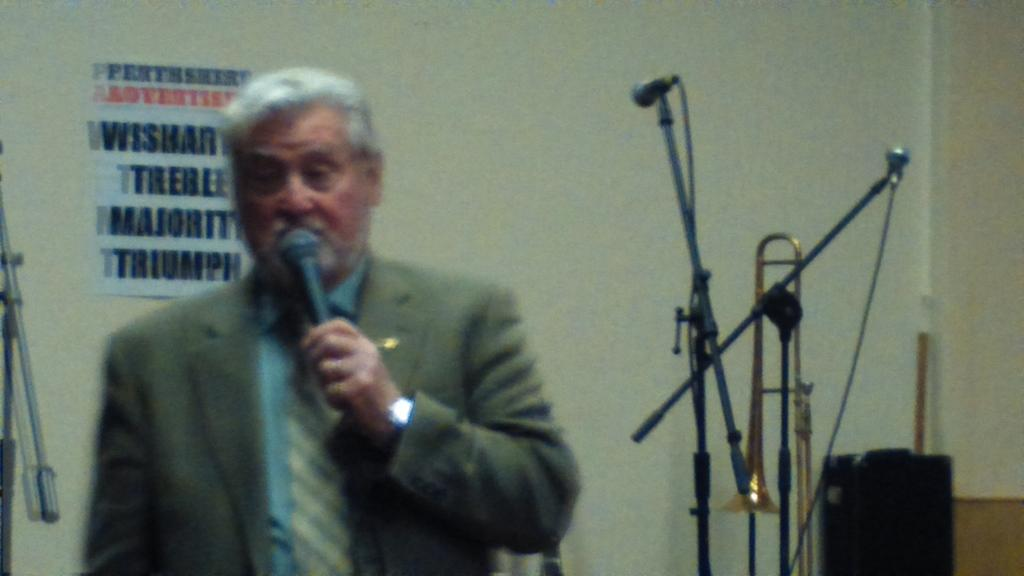What is the man in the image doing? The man is standing and talking into a microphone. What can be seen in the background of the image? There are microphones, trombones, a wall, a wall poster, and a speaker in the background of the image. How many microphones are visible in the image? There is one microphone being used by the man and at least one more in the background, so there are at least two microphones visible. What type of power does the man's throat have in the image? There is no indication of any special power in the man's throat in the image. 